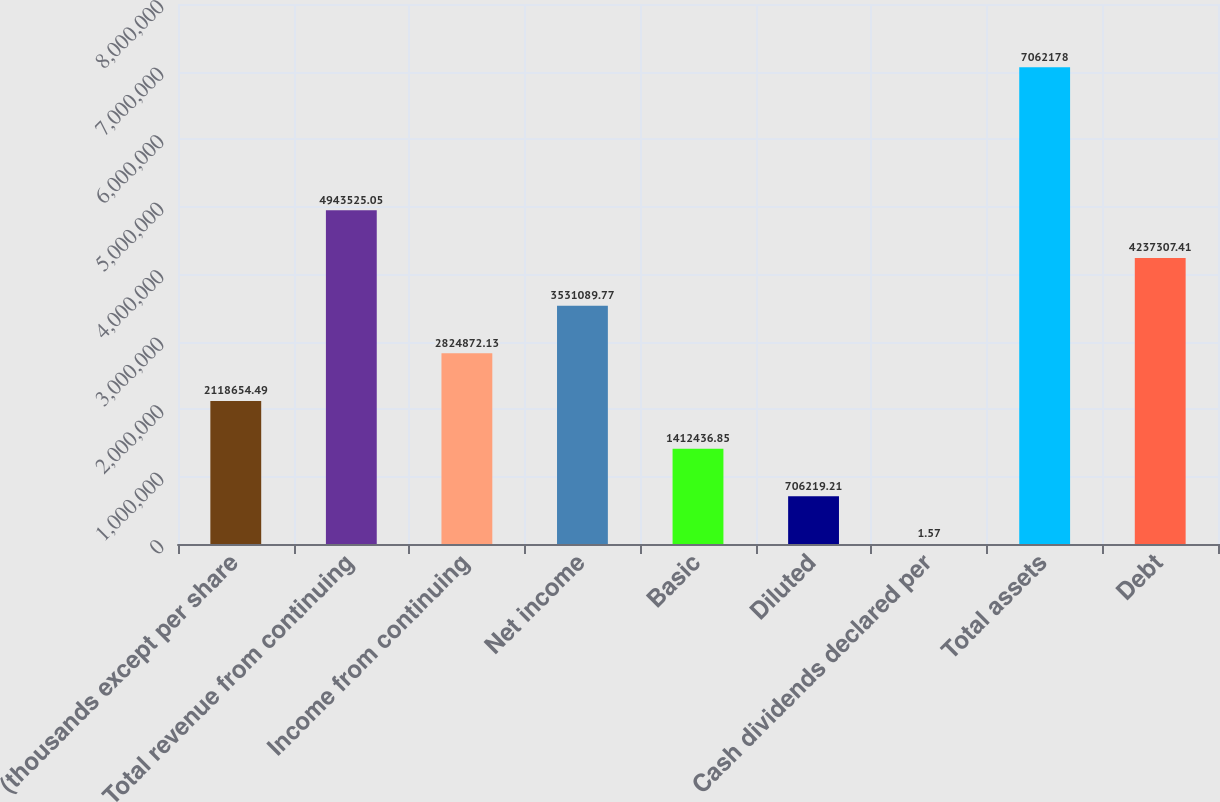Convert chart. <chart><loc_0><loc_0><loc_500><loc_500><bar_chart><fcel>(thousands except per share<fcel>Total revenue from continuing<fcel>Income from continuing<fcel>Net income<fcel>Basic<fcel>Diluted<fcel>Cash dividends declared per<fcel>Total assets<fcel>Debt<nl><fcel>2.11865e+06<fcel>4.94353e+06<fcel>2.82487e+06<fcel>3.53109e+06<fcel>1.41244e+06<fcel>706219<fcel>1.57<fcel>7.06218e+06<fcel>4.23731e+06<nl></chart> 